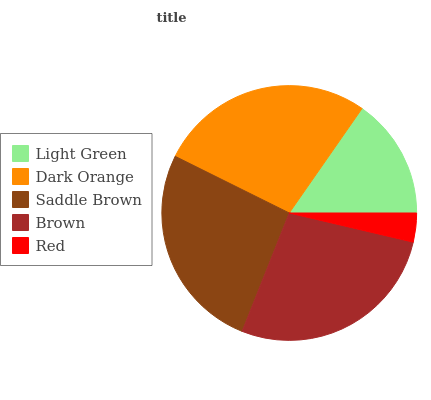Is Red the minimum?
Answer yes or no. Yes. Is Brown the maximum?
Answer yes or no. Yes. Is Dark Orange the minimum?
Answer yes or no. No. Is Dark Orange the maximum?
Answer yes or no. No. Is Dark Orange greater than Light Green?
Answer yes or no. Yes. Is Light Green less than Dark Orange?
Answer yes or no. Yes. Is Light Green greater than Dark Orange?
Answer yes or no. No. Is Dark Orange less than Light Green?
Answer yes or no. No. Is Saddle Brown the high median?
Answer yes or no. Yes. Is Saddle Brown the low median?
Answer yes or no. Yes. Is Red the high median?
Answer yes or no. No. Is Dark Orange the low median?
Answer yes or no. No. 